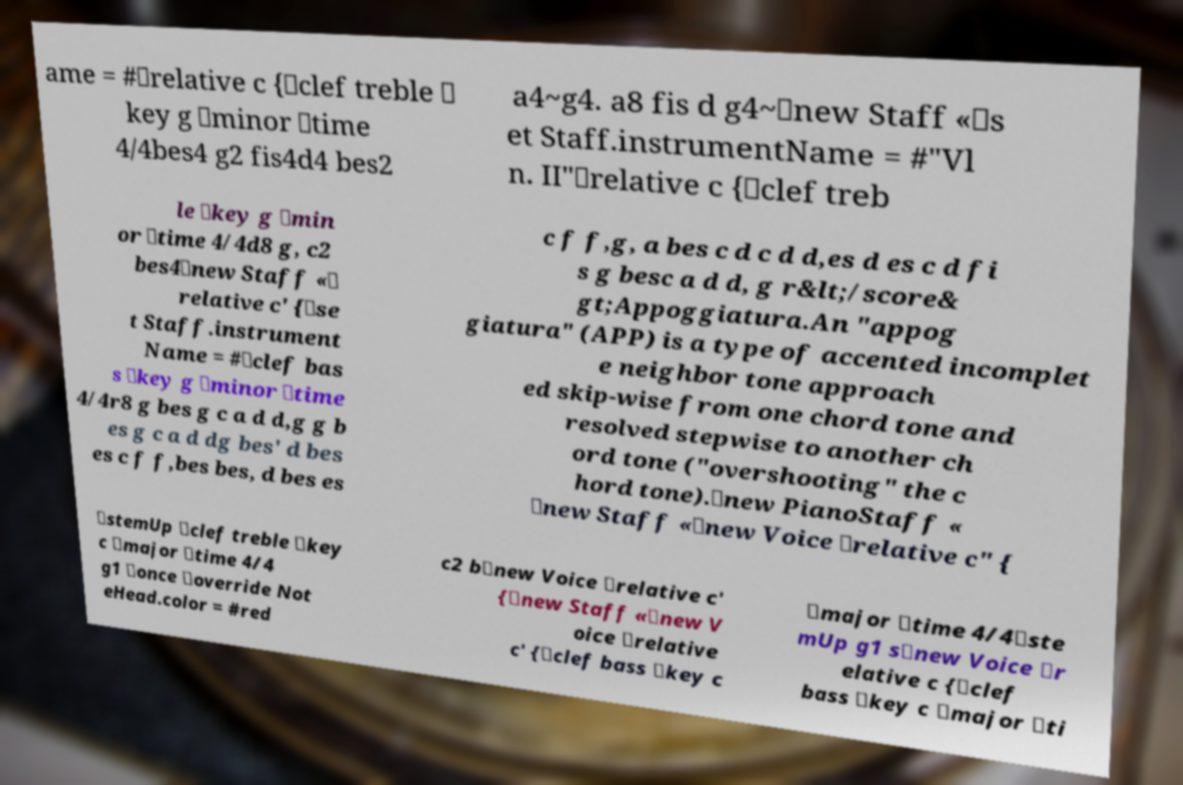There's text embedded in this image that I need extracted. Can you transcribe it verbatim? ame = #\relative c {\clef treble \ key g \minor \time 4/4bes4 g2 fis4d4 bes2 a4~g4. a8 fis d g4~\new Staff «\s et Staff.instrumentName = #"Vl n. II"\relative c {\clef treb le \key g \min or \time 4/4d8 g, c2 bes4\new Staff «\ relative c' {\se t Staff.instrument Name = #\clef bas s \key g \minor \time 4/4r8 g bes g c a d d,g g b es g c a d dg bes' d bes es c f f,bes bes, d bes es c f f,g, a bes c d c d d,es d es c d fi s g besc a d d, g r&lt;/score& gt;Appoggiatura.An "appog giatura" (APP) is a type of accented incomplet e neighbor tone approach ed skip-wise from one chord tone and resolved stepwise to another ch ord tone ("overshooting" the c hord tone).\new PianoStaff « \new Staff «\new Voice \relative c" { \stemUp \clef treble \key c \major \time 4/4 g1 \once \override Not eHead.color = #red c2 b\new Voice \relative c' {\new Staff «\new V oice \relative c' {\clef bass \key c \major \time 4/4\ste mUp g1 s\new Voice \r elative c {\clef bass \key c \major \ti 